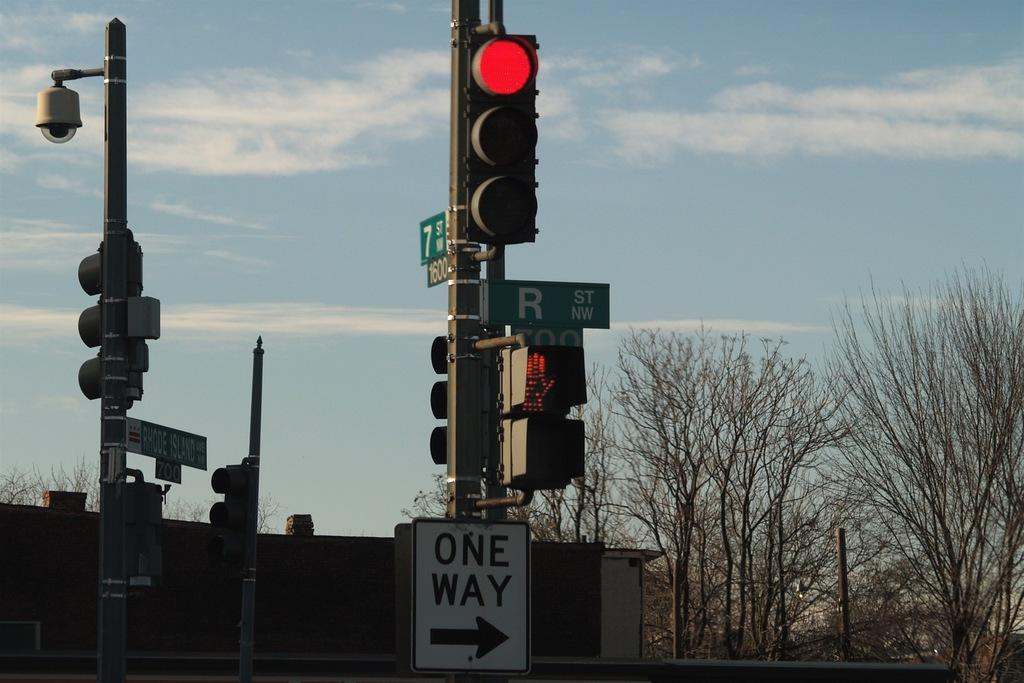<image>
Give a short and clear explanation of the subsequent image. a one way sign that is under a large light 